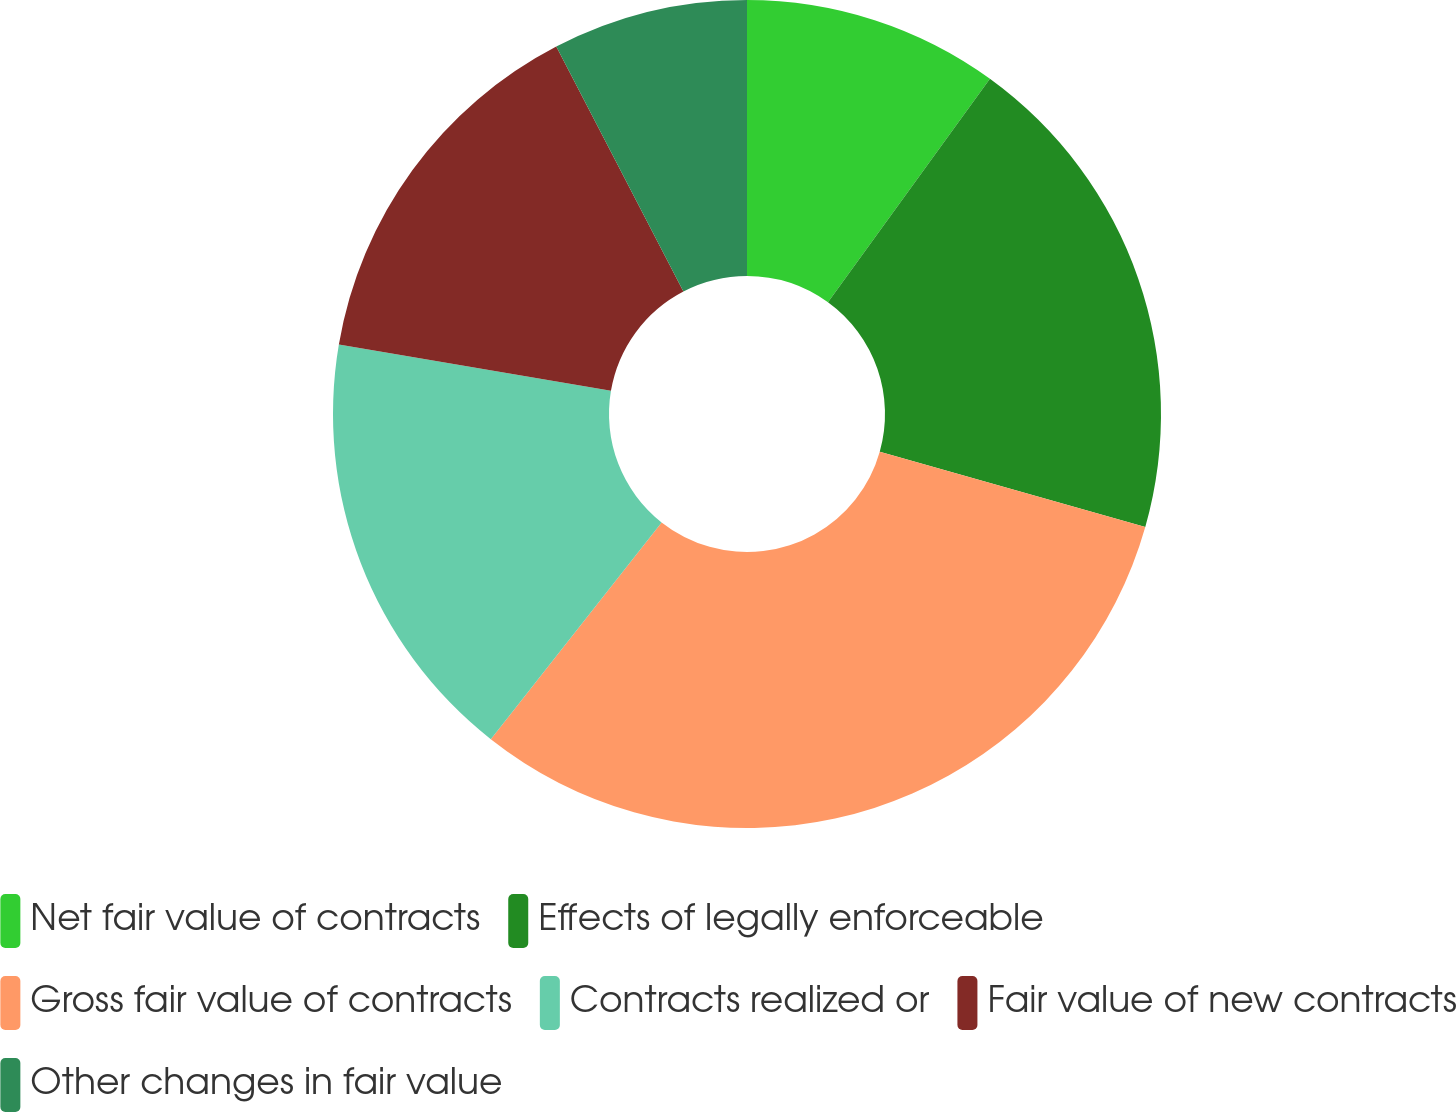<chart> <loc_0><loc_0><loc_500><loc_500><pie_chart><fcel>Net fair value of contracts<fcel>Effects of legally enforceable<fcel>Gross fair value of contracts<fcel>Contracts realized or<fcel>Fair value of new contracts<fcel>Other changes in fair value<nl><fcel>9.98%<fcel>19.42%<fcel>31.22%<fcel>17.06%<fcel>14.7%<fcel>7.62%<nl></chart> 